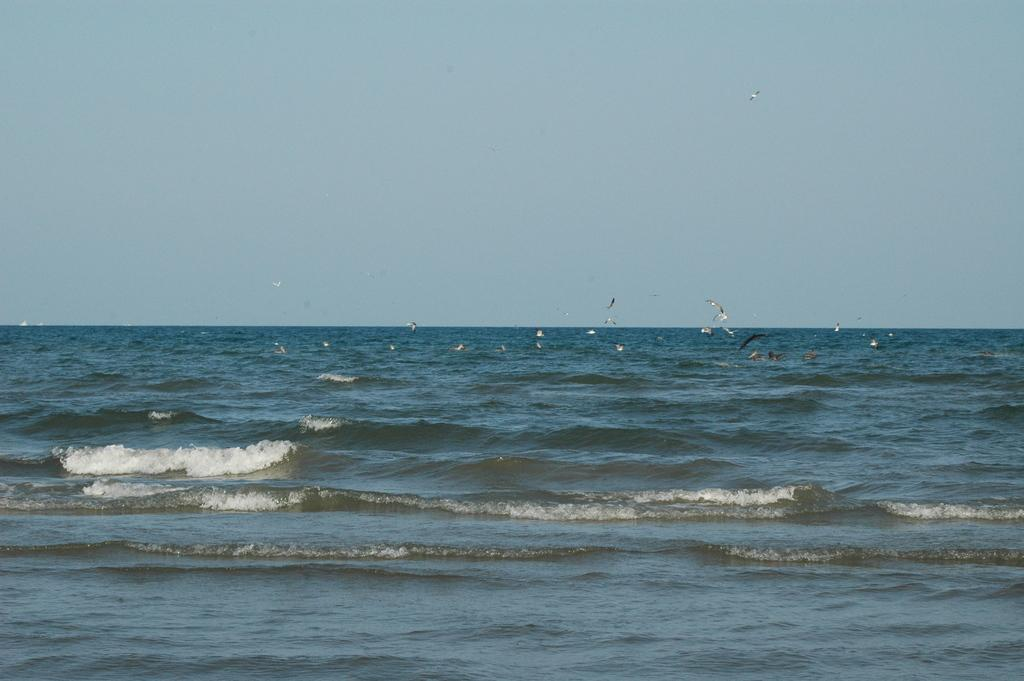What is located in the center of the image? There is water and birds in the center of the image. What can be seen above the water in the image? The sky is visible in the image. What type of quiver can be seen in the image? There is no quiver present in the image. Is there a railway visible in the image? No, there is no railway visible in the image. 